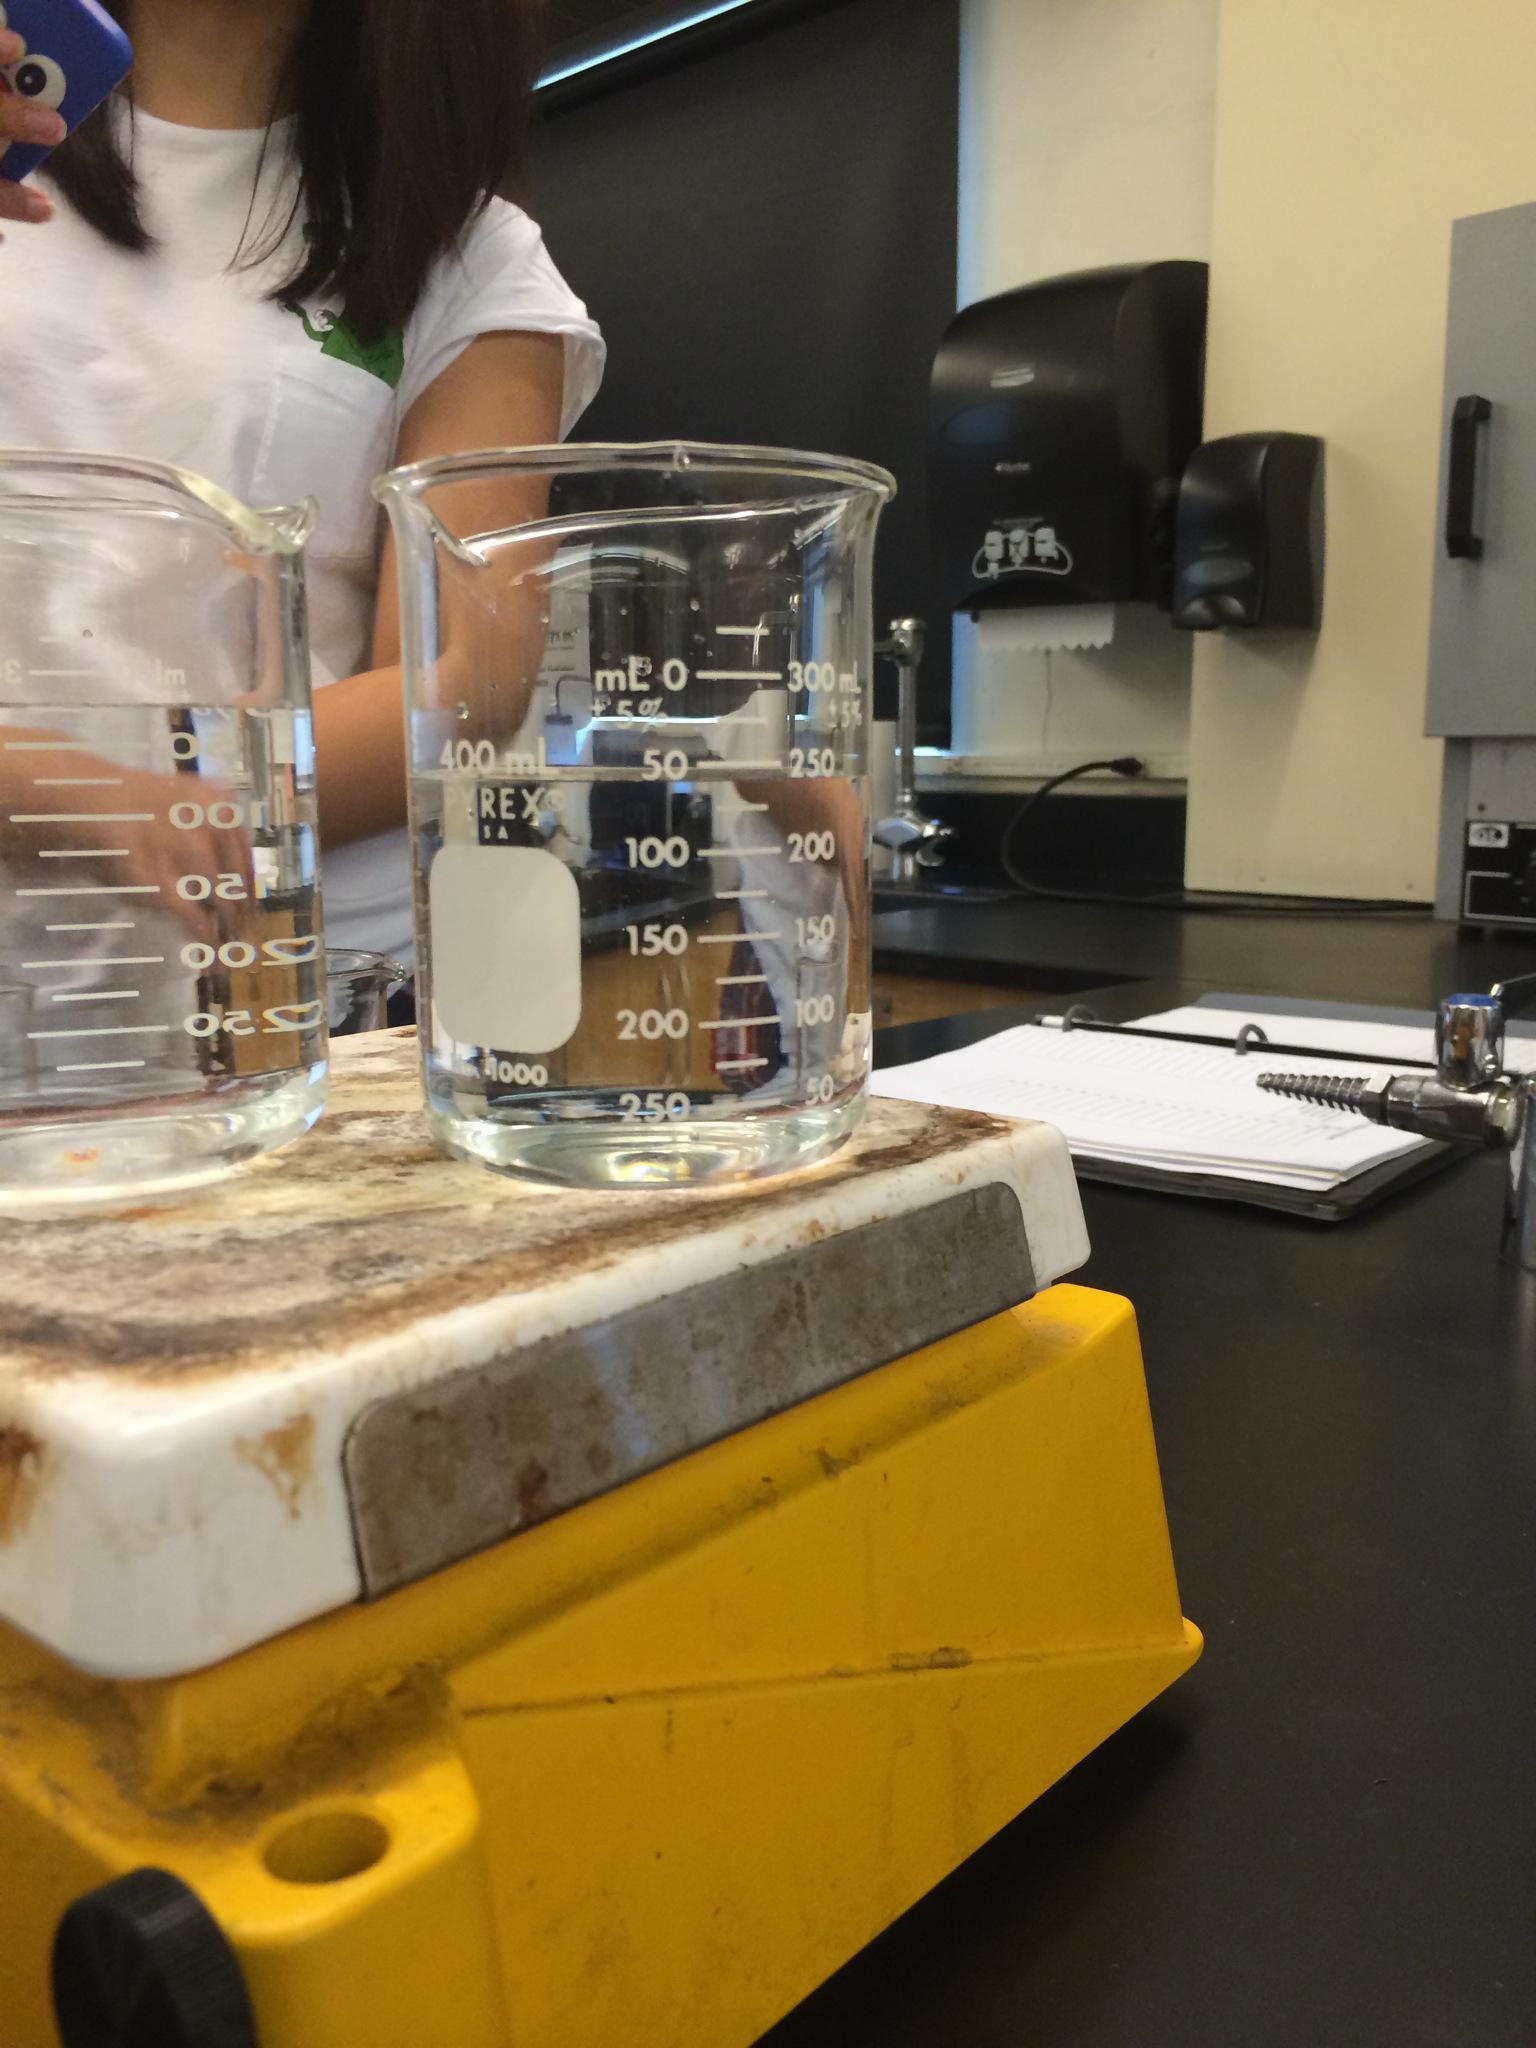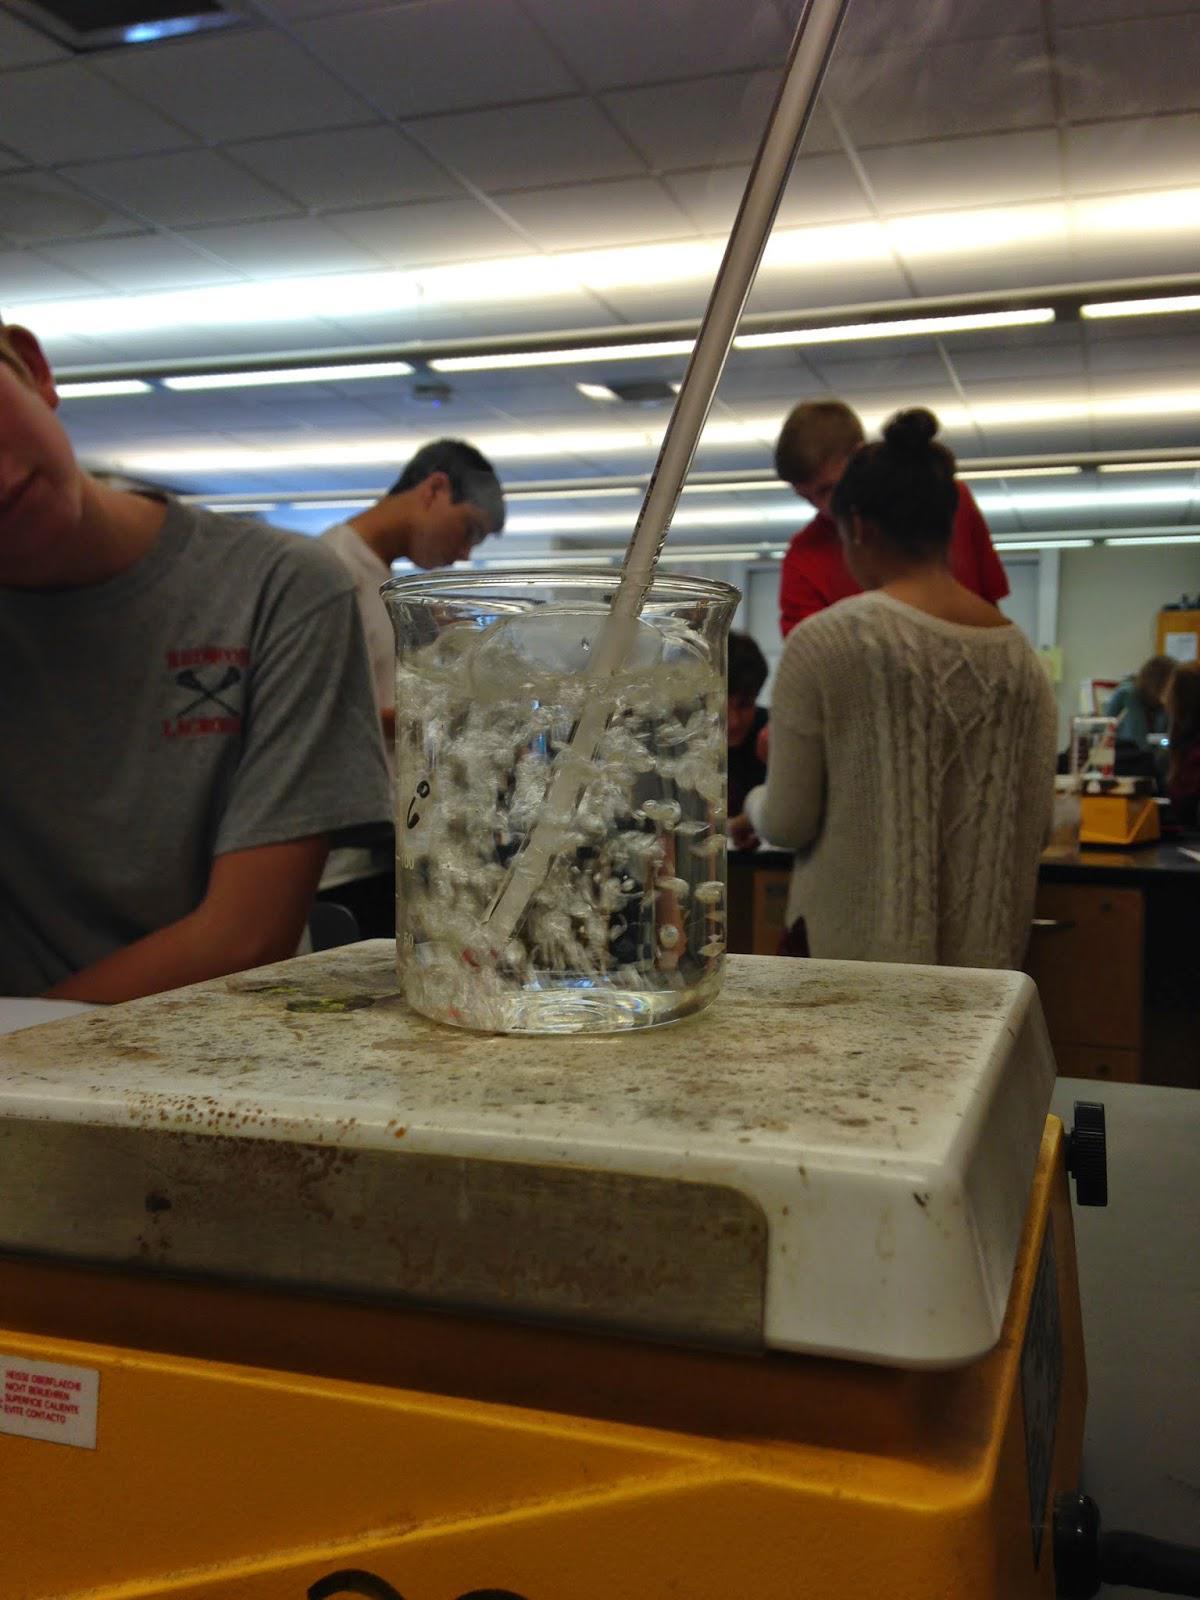The first image is the image on the left, the second image is the image on the right. Analyze the images presented: Is the assertion "There appear to be exactly three containers visible." valid? Answer yes or no. Yes. 